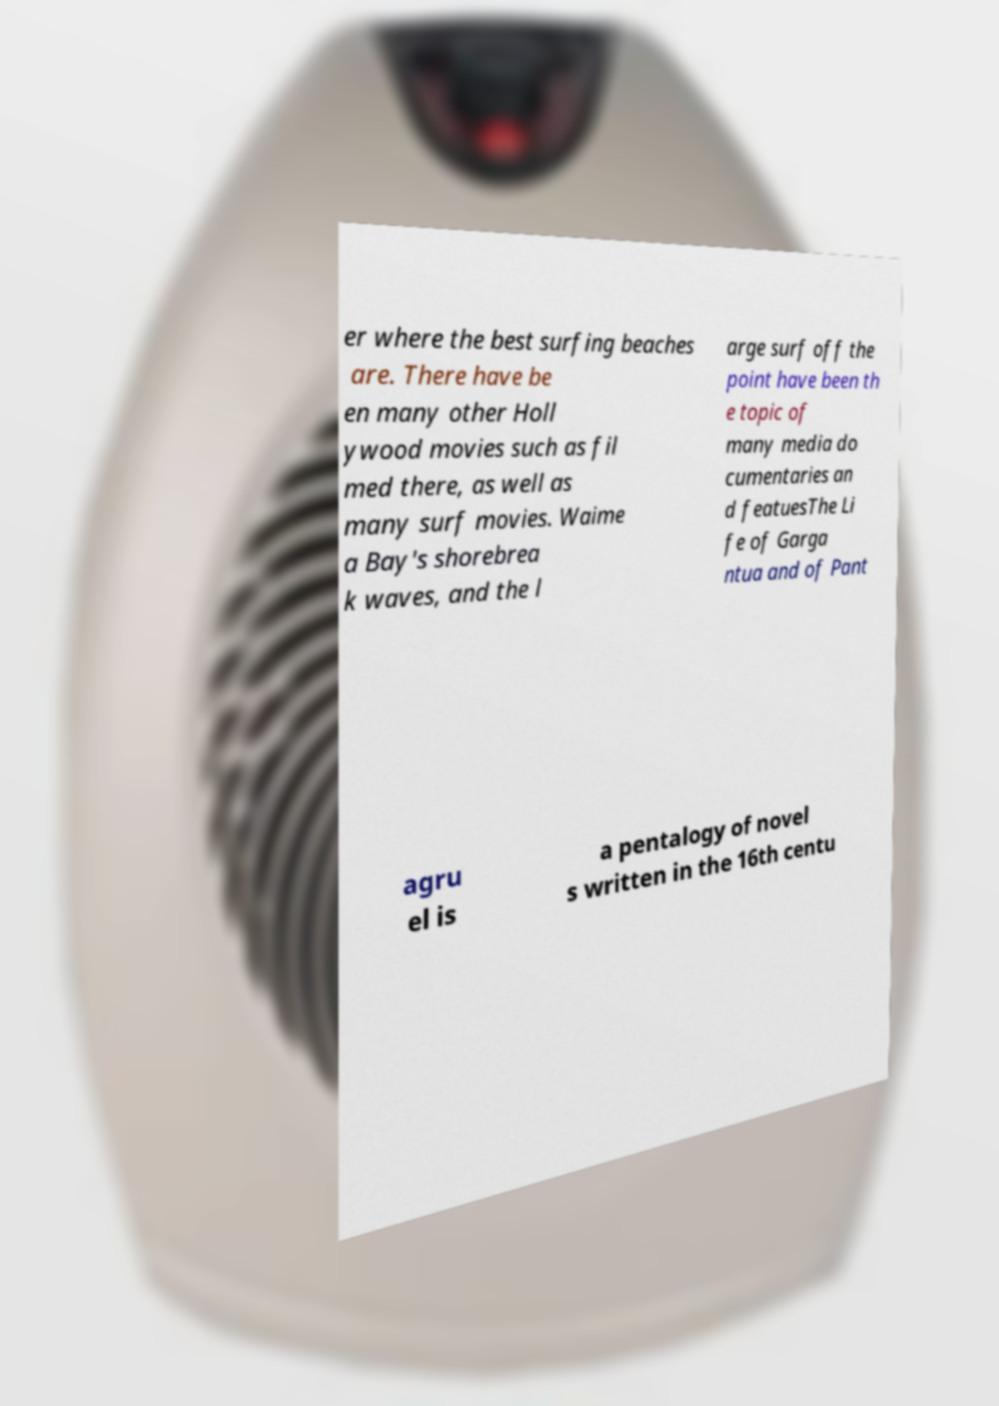There's text embedded in this image that I need extracted. Can you transcribe it verbatim? er where the best surfing beaches are. There have be en many other Holl ywood movies such as fil med there, as well as many surf movies. Waime a Bay's shorebrea k waves, and the l arge surf off the point have been th e topic of many media do cumentaries an d featuesThe Li fe of Garga ntua and of Pant agru el is a pentalogy of novel s written in the 16th centu 